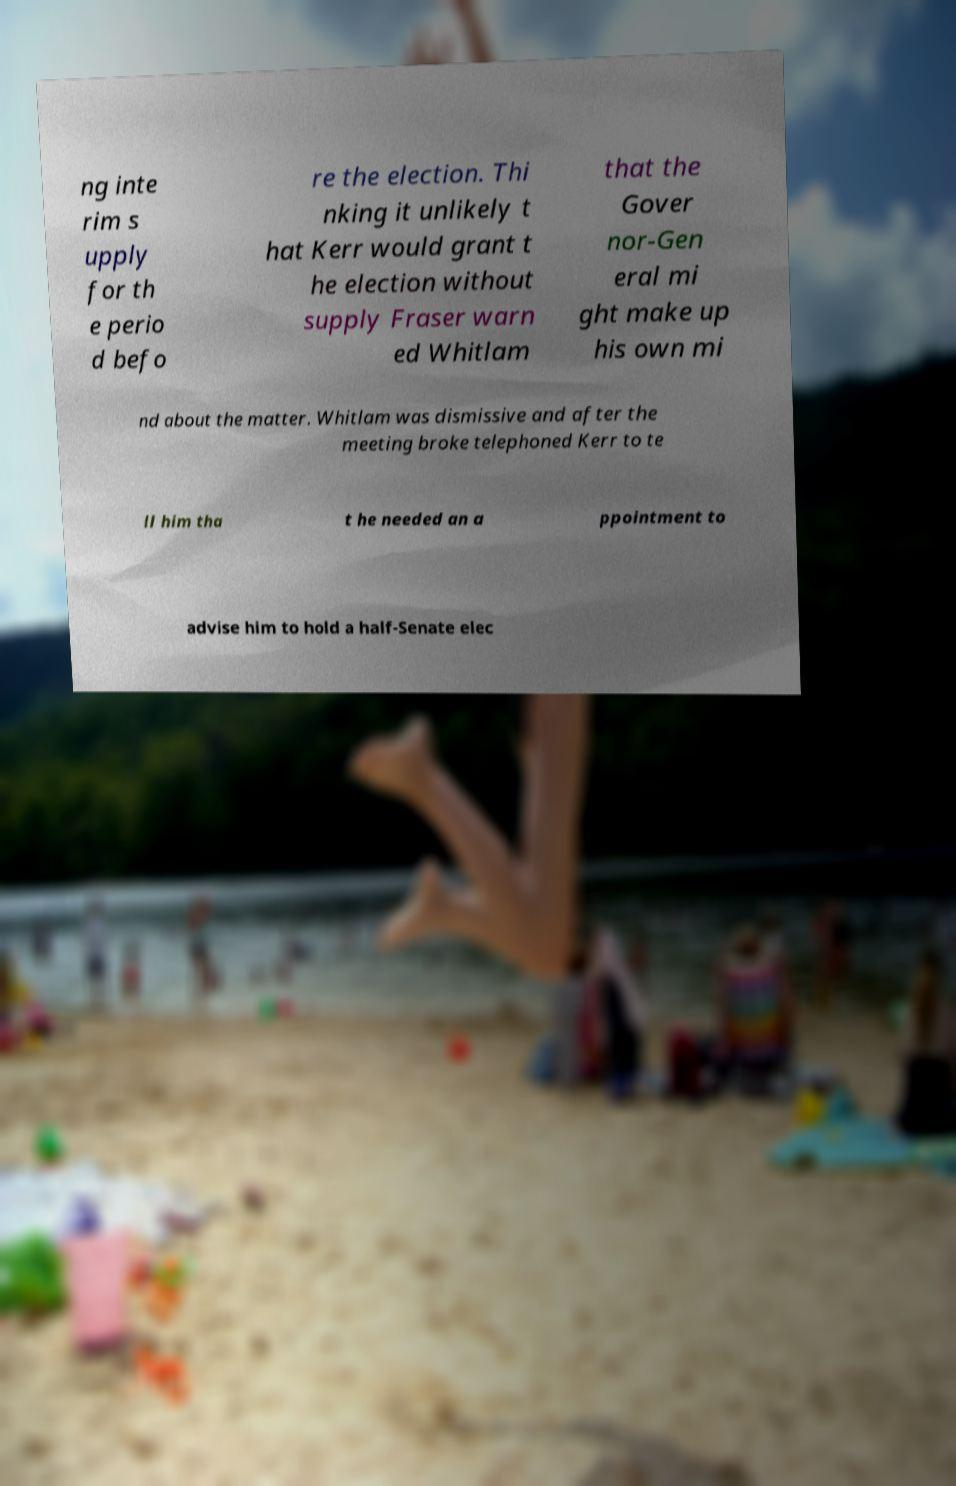Could you extract and type out the text from this image? ng inte rim s upply for th e perio d befo re the election. Thi nking it unlikely t hat Kerr would grant t he election without supply Fraser warn ed Whitlam that the Gover nor-Gen eral mi ght make up his own mi nd about the matter. Whitlam was dismissive and after the meeting broke telephoned Kerr to te ll him tha t he needed an a ppointment to advise him to hold a half-Senate elec 